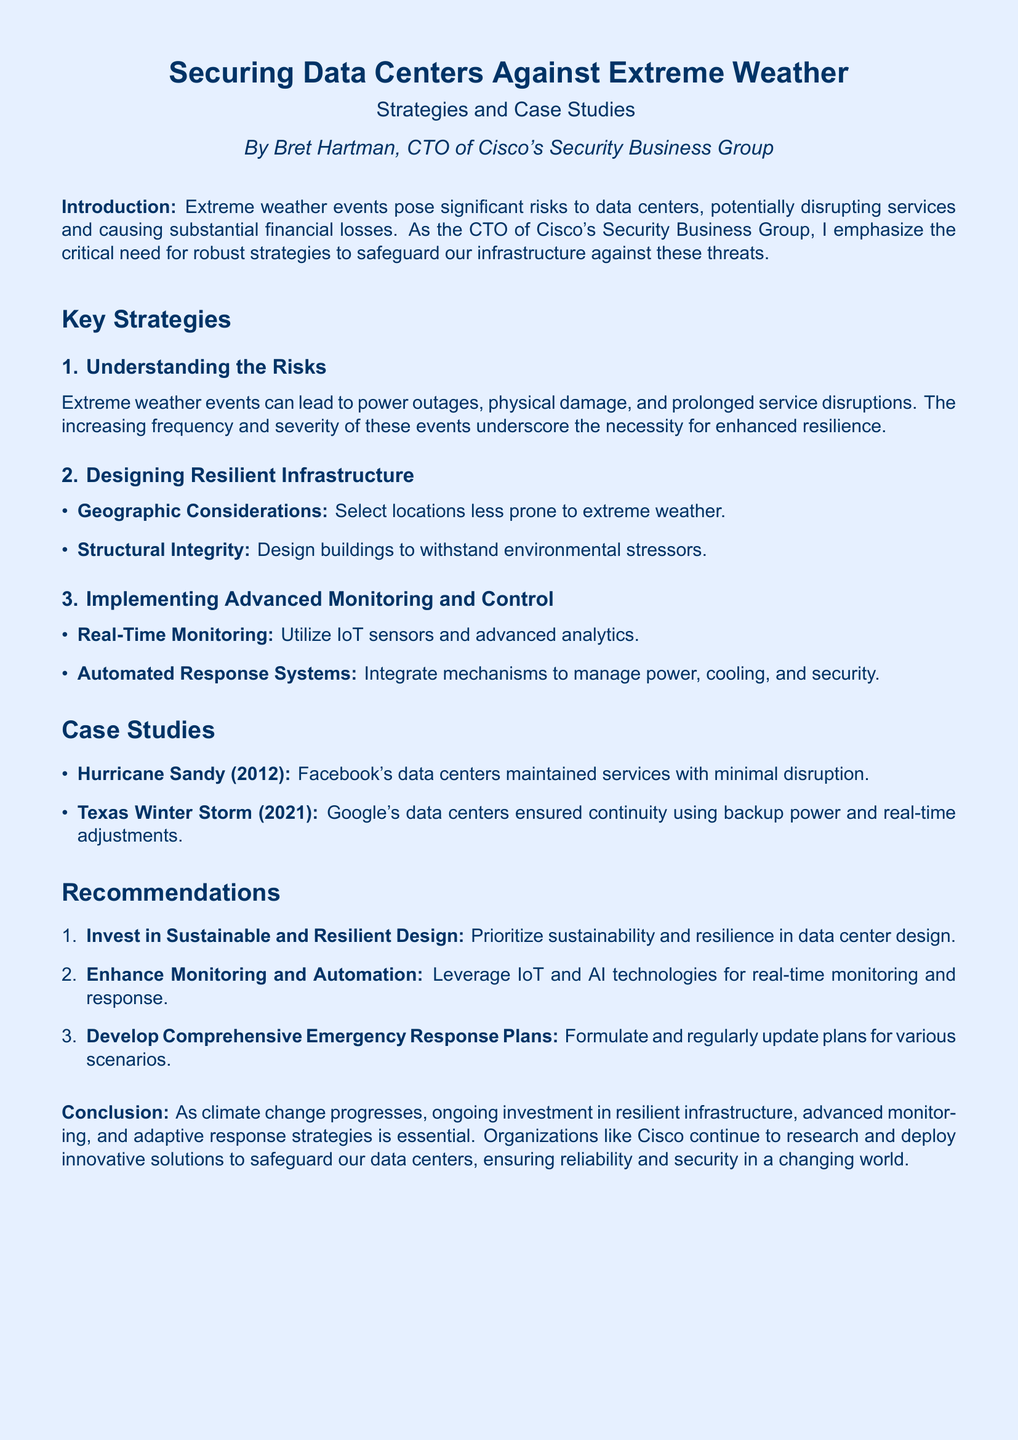What is the title of the document? The title is prominently displayed at the top of the document.
Answer: Securing Data Centers Against Extreme Weather Who is the author of the report? The author's name is stated in the introduction section.
Answer: Bret Hartman What major extreme weather event is referenced in a case study? The case study highlights significant weather events related to data center performance.
Answer: Hurricane Sandy What is one recommendation given in the document? The recommendations section lists strategies to enhance resilience and security.
Answer: Invest in Sustainable and Resilient Design What monitoring technology is suggested for data centers? The document mentions specific technologies for enhancing monitoring systems.
Answer: IoT sensors and advanced analytics How many main strategies are listed in the document? The introduction mentions key strategies, which are detailed further in the document.
Answer: Three What year did the Texas Winter Storm occur? This information is provided within the context of case studies related to data center operations.
Answer: 2021 What does the acronym "AI" stand for in the recommendations section? The document discusses technologies, and AI is a highlighted component for monitoring.
Answer: Artificial Intelligence Which company maintained services during Hurricane Sandy? A specific company is mentioned in relation to the success of their data center continuity.
Answer: Facebook 